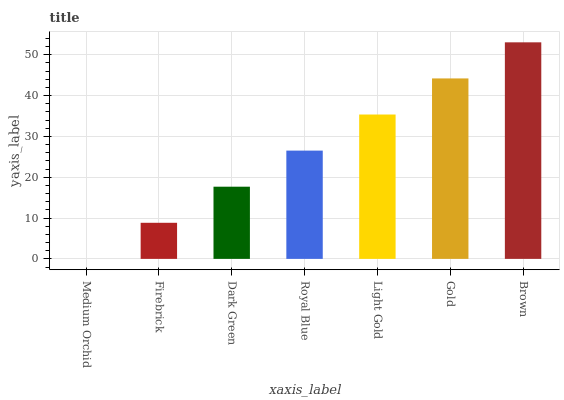Is Medium Orchid the minimum?
Answer yes or no. Yes. Is Brown the maximum?
Answer yes or no. Yes. Is Firebrick the minimum?
Answer yes or no. No. Is Firebrick the maximum?
Answer yes or no. No. Is Firebrick greater than Medium Orchid?
Answer yes or no. Yes. Is Medium Orchid less than Firebrick?
Answer yes or no. Yes. Is Medium Orchid greater than Firebrick?
Answer yes or no. No. Is Firebrick less than Medium Orchid?
Answer yes or no. No. Is Royal Blue the high median?
Answer yes or no. Yes. Is Royal Blue the low median?
Answer yes or no. Yes. Is Medium Orchid the high median?
Answer yes or no. No. Is Dark Green the low median?
Answer yes or no. No. 